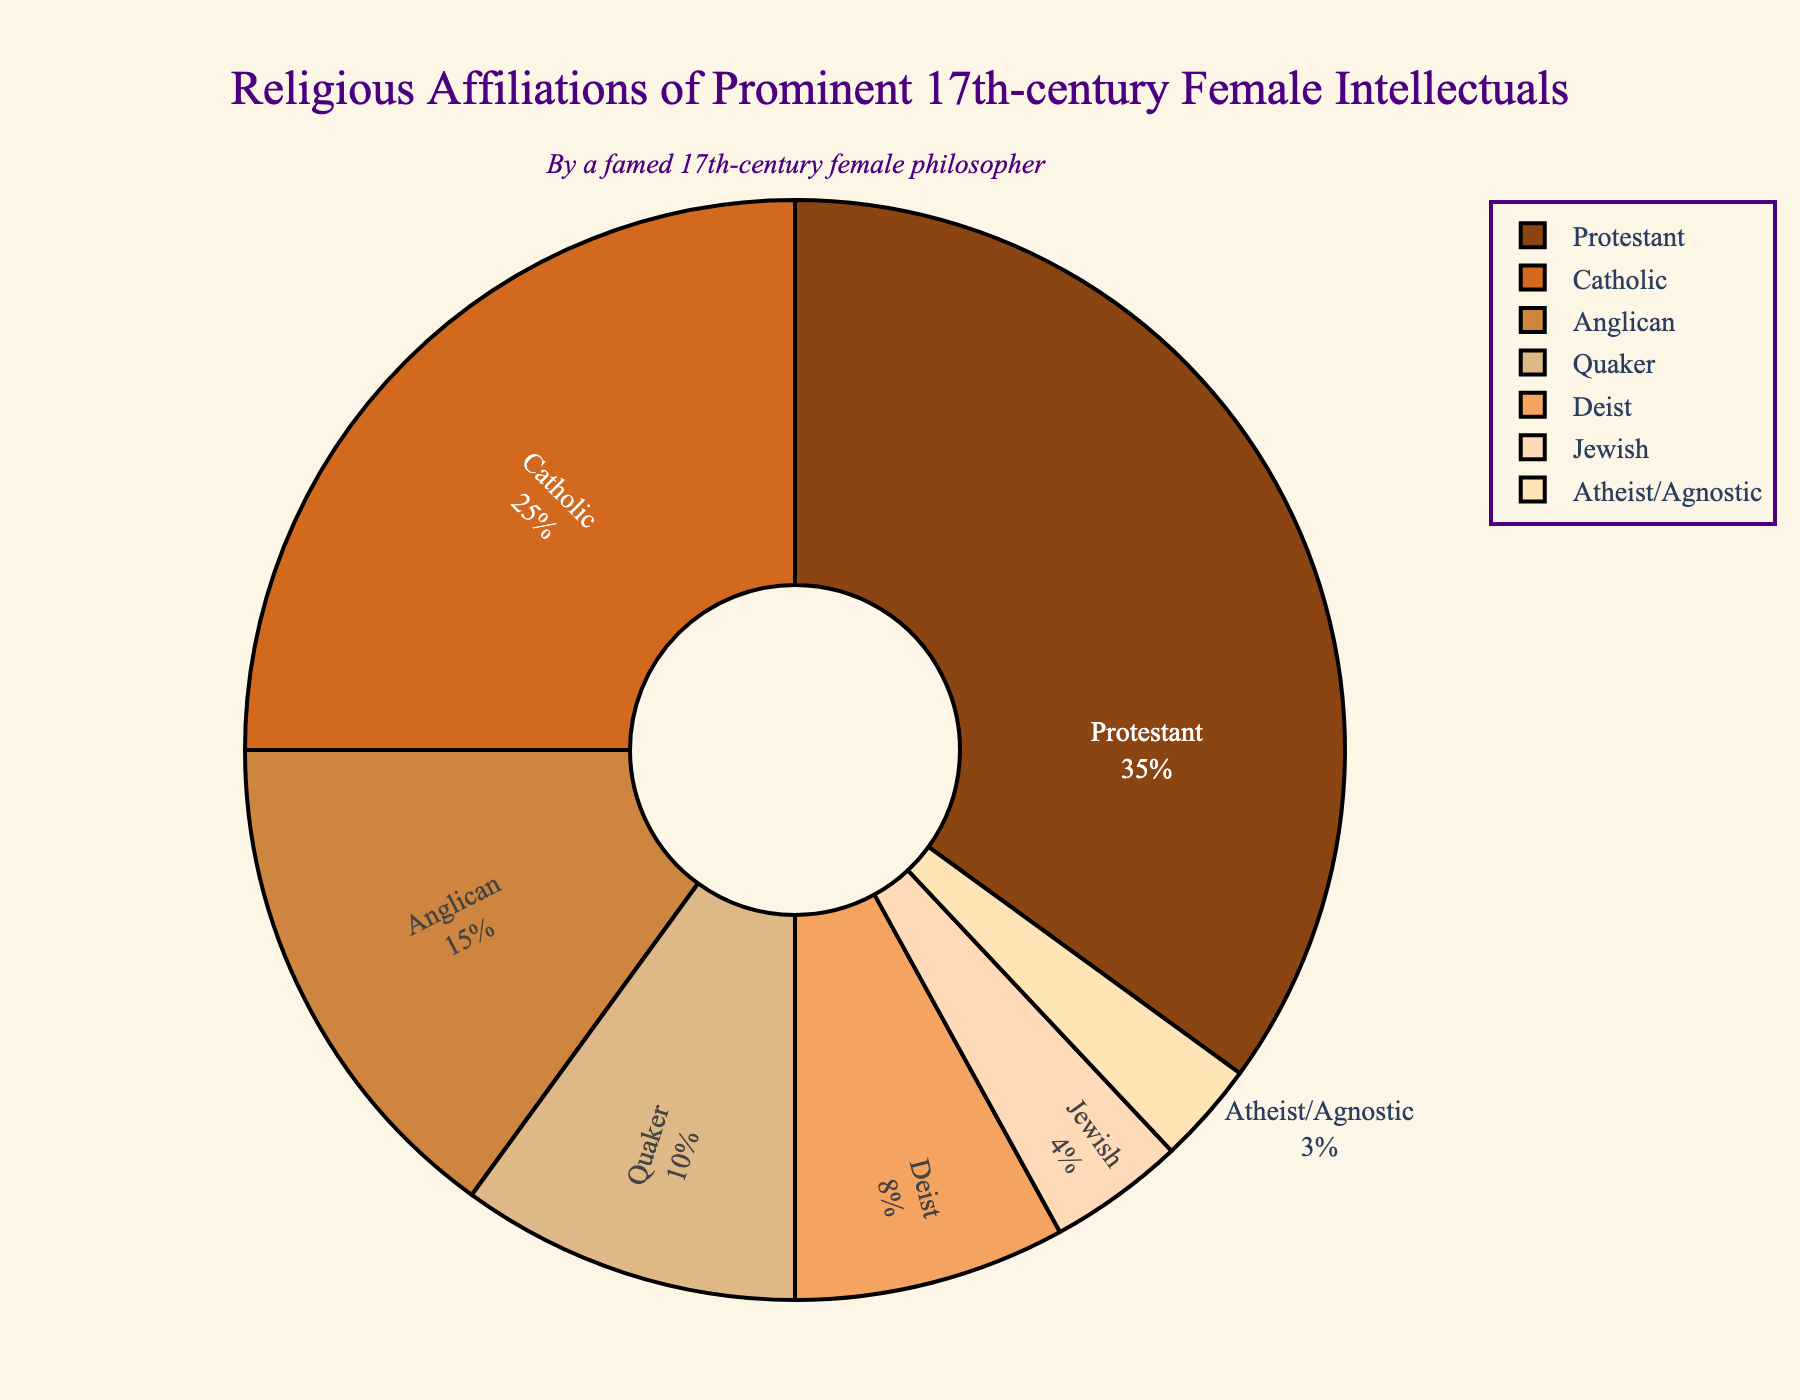What is the most common religious affiliation among the prominent 17th-century female intellectuals? Step 1: Look at the pie chart to identify the largest slice. Step 2: Note the label of this largest slice.
Answer: Protestant Which two religious affiliations together make up the majority of the affiliations? Step 1: Sum the percentages for each slice until you reach a value greater than 50%. Step 2: Identify the two largest slices and sum their percentages: 35% (Protestant) + 25% (Catholic) = 60%.
Answer: Protestant and Catholic What percentage of the affiliations are either Quaker or Deist? Step 1: Identify the percentages for Quaker (10%) and Deist (8%) slices. Step 2: Add the two percentages: 10% + 8% = 18%.
Answer: 18% Which religious affiliation has the smallest representation? Step 1: Look for the smallest slice in the pie chart. Step 2: Note the label of this smallest slice.
Answer: Atheist/Agnostic How much more common is Protestantism compared to Anglicanism? Step 1: Identify the percentages for Protestant (35%) and Anglican (15%) slices. Step 2: Subtract the Anglican percentage from the Protestant percentage: 35% - 15% = 20%.
Answer: 20% Which religious affiliations have a lower representation than Anglicanism? Step 1: Identify the percentage for Anglicanism (15%). Step 2: List the religious affiliations with percentages lower than 15%: Quaker (10%), Deist (8%), Jewish (4%), and Atheist/Agnostic (3%).
Answer: Quaker, Deist, Jewish, Atheist/Agnostic What is the average percentage of all religious affiliations depicted in the chart? Step 1: Identify the percentages for all slices: (35%, 25%, 15%, 10%, 8%, 4%, 3%). Step 2: Calculate the sum of these percentages: 35 + 25 + 15 + 10 + 8 + 4 + 3 = 100%. Step 3: Divide this sum by the number of affiliations: 100% / 7 ≈ 14.29%.
Answer: ~14.29% Is the percentage of Catholic affiliations greater than the combined percentage of Jewish and Atheist/Agnostic affiliations? Step 1: Identify the percentages for Catholic (25%), Jewish (4%), and Atheist/Agnostic (3%). Step 2: Sum the percentages of Jewish and Atheist/Agnostic: 4% + 3% = 7%. Step 3: Compare 25% (Catholic) to 7% (Jewish + Atheist/Agnostic).
Answer: Yes How many religious affiliations have at least twice the percentage of Atheist/Agnostic affiliations? Step 1: Identify the percentage of Atheist/Agnostic (3%). Step 2: Find at least twice this percentage: 3% × 2 = 6%. Step 3: Count the affiliations with a percentage greater than or equal to 6%: Protestant (35%), Catholic (25%), Anglican (15%), Quaker (10%), Deist (8%).
Answer: 5 